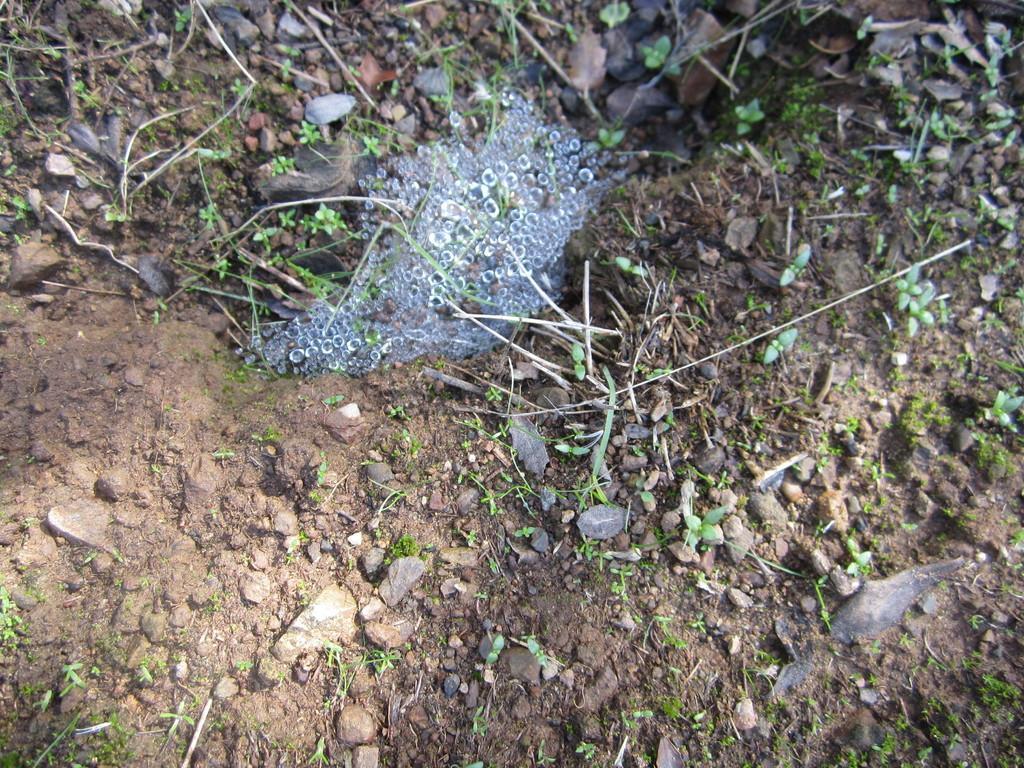Please provide a concise description of this image. The picture consists of plants, stones and soil. In the center of the picture it is water. 